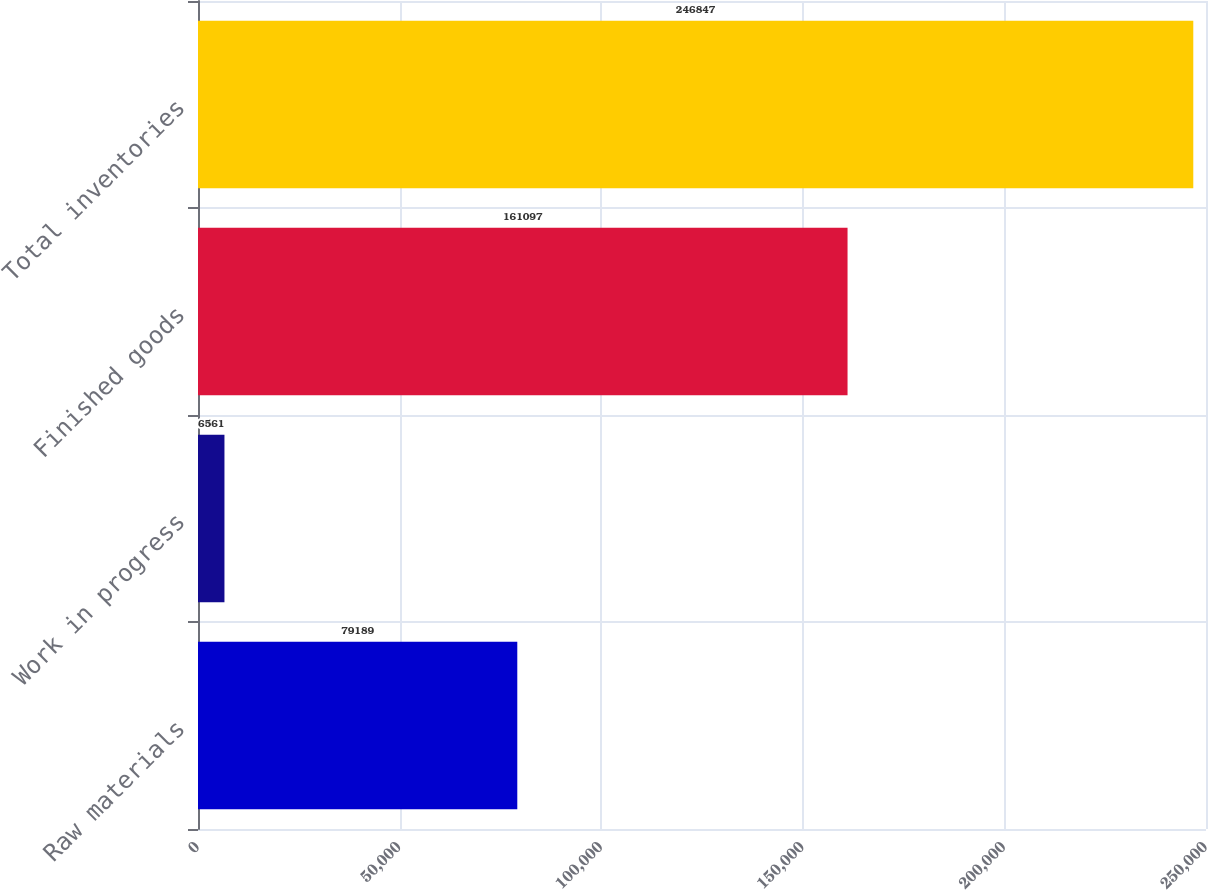<chart> <loc_0><loc_0><loc_500><loc_500><bar_chart><fcel>Raw materials<fcel>Work in progress<fcel>Finished goods<fcel>Total inventories<nl><fcel>79189<fcel>6561<fcel>161097<fcel>246847<nl></chart> 